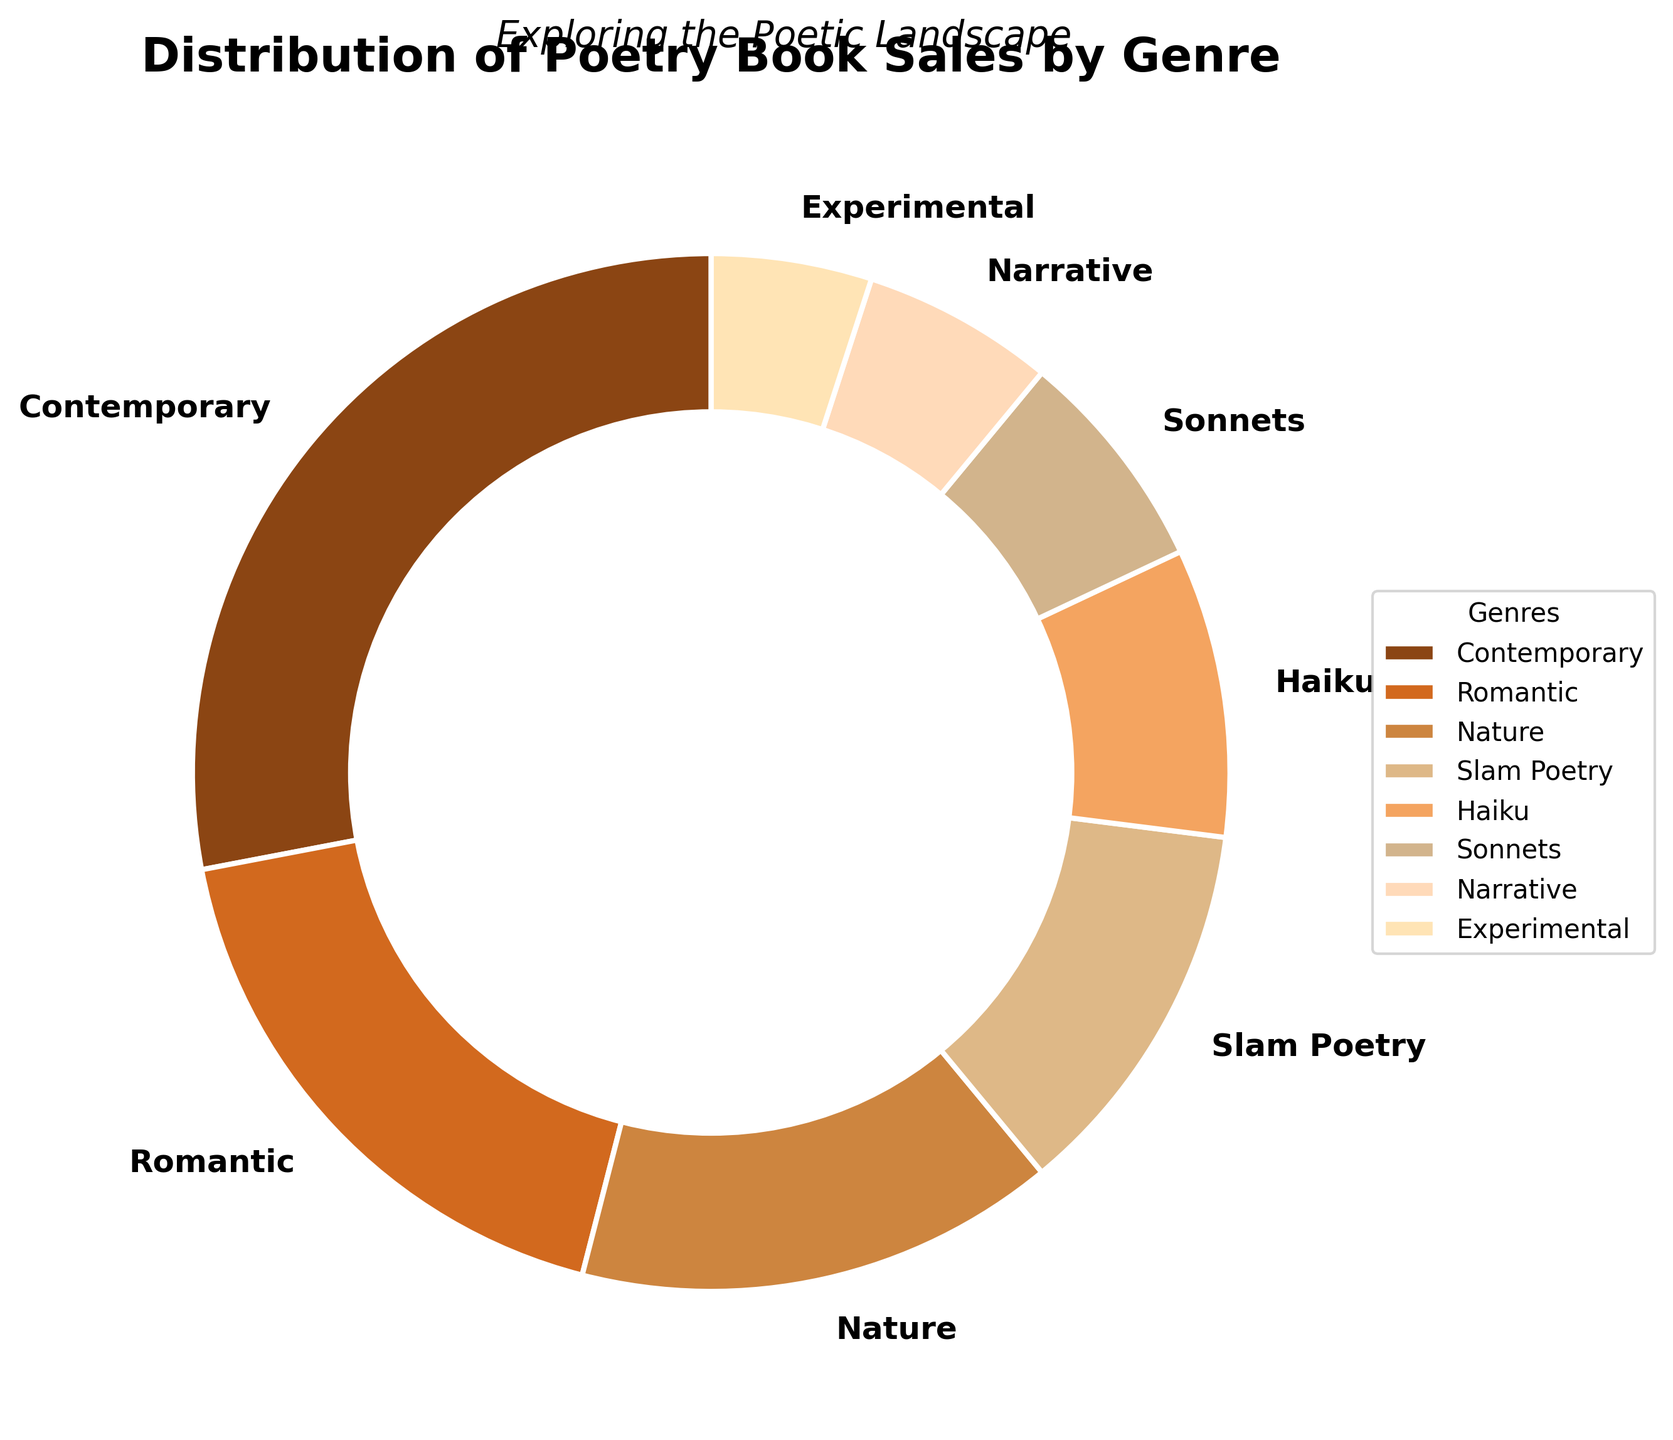What percentage of poetry book sales does Romantic poetry represent? The chart shows "Romantic" poetry with a label indicating its sales percentage.
Answer: 18% What is the percentage difference between Contemporary and Romantic poetry sales? According to the figure, Contemporary poetry represents 28% of sales and Romantic poetry represents 18%. The difference is 28% - 18% = 10%.
Answer: 10% Which genre has the smallest share of poetry book sales? The figure shows that "Experimental" poetry has the smallest wedge, labeled with a percentage of 5%.
Answer: Experimental Combine the sales percentages of Haiku and Sonnets. What is the total? The chart shows Haiku at 9% and Sonnets at 7%. Adding these together gives 9% + 7% = 16%.
Answer: 16% Is the percentage of sales for Nature poetry greater than for Slam Poetry? The figure shows Nature poetry represents 15% and Slam Poetry represents 12%. Since 15% is more than 12%, Nature poetry has a greater percentage of sales.
Answer: Yes What is the total percentage of sales for genres other than Contemporary poetry? First, recognize the total percentage of sales must equal 100%. Contemporary poetry represents 28%. Subtracting this from 100% gives us 100% - 28% = 72%.
Answer: 72% Which genre's sales are closest to one-third of Contemporary poetry sales? One-third of Contemporary poetry sales is 28% / 3 ≈ 9.33%. Haiku sales represent 9%, which is the closest value.
Answer: Haiku Compare the combined sales of Romantic and Nature poetry to Contemporary poetry. Are they higher or lower? Romantic poetry is 18% and Nature poetry is 15%. Combined, this is 18% + 15% = 33%. Contemporary poetry sales are at 28%. Since 33% is higher than 28%, they are higher.
Answer: Higher What percentage of total sales do the genres with less than 10% market share collectively represent? Adding the percentages for Haiku (9%), Sonnets (7%), Narrative (6%), and Experimental (5%) gives 9% + 7% + 6% + 5% = 27%.
Answer: 27% 